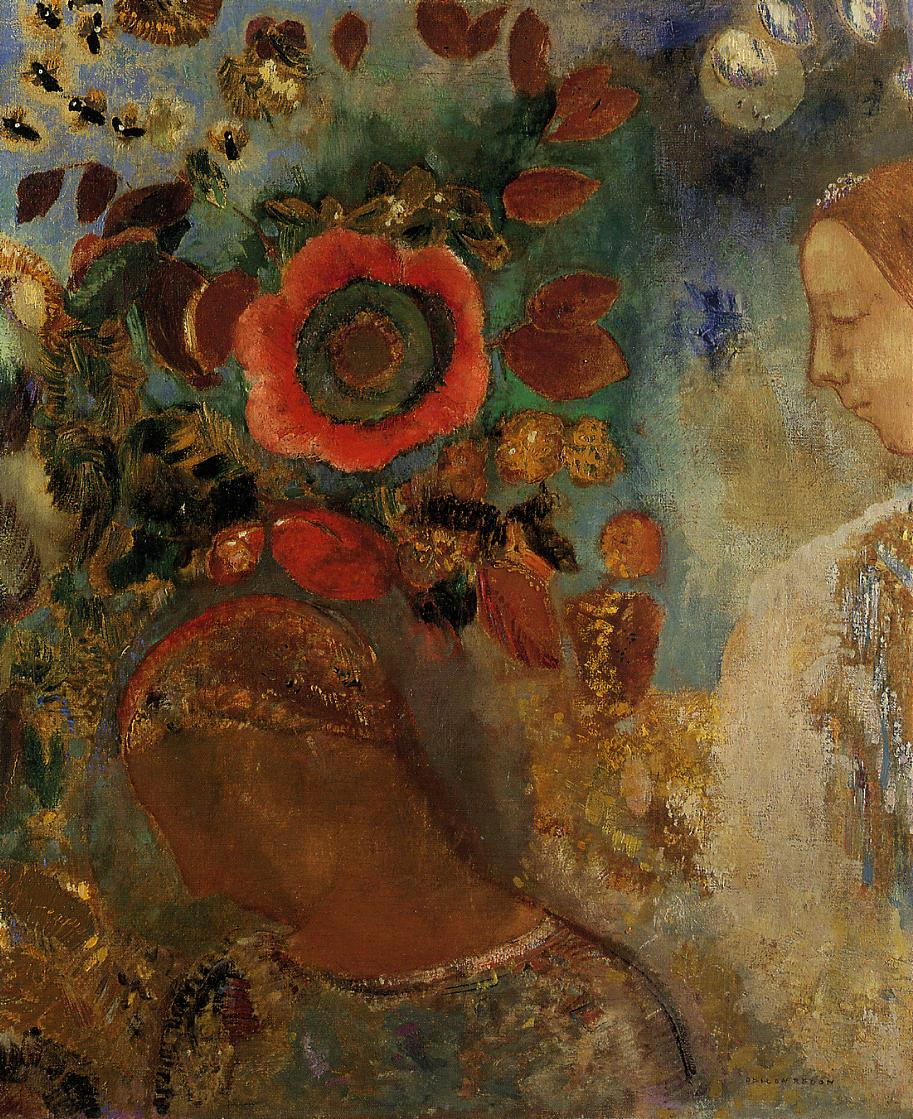If this painting were to be turned into a scene in an animated film, how might it be depicted? Enhanced with soft, flowing animations, the scene would come to life with the gentle swaying of the flowers and the subtle glow of the large red bloom pulsating like a heartbeat. The serene expression of the woman would animate into slight movements, her eyes closing in a meditative reverie while faint, ethereal music underscores the peace of the garden. Wisps of light might dance around the flowers, hinting at unseen magical entities, while the colors shift and blend seamlessly, evoking the impressionistic style of the original artwork. This dynamic interpretation would emphasize the tranquil, almost magical nature of the scene, making it a moment of visual poetry in the film.  